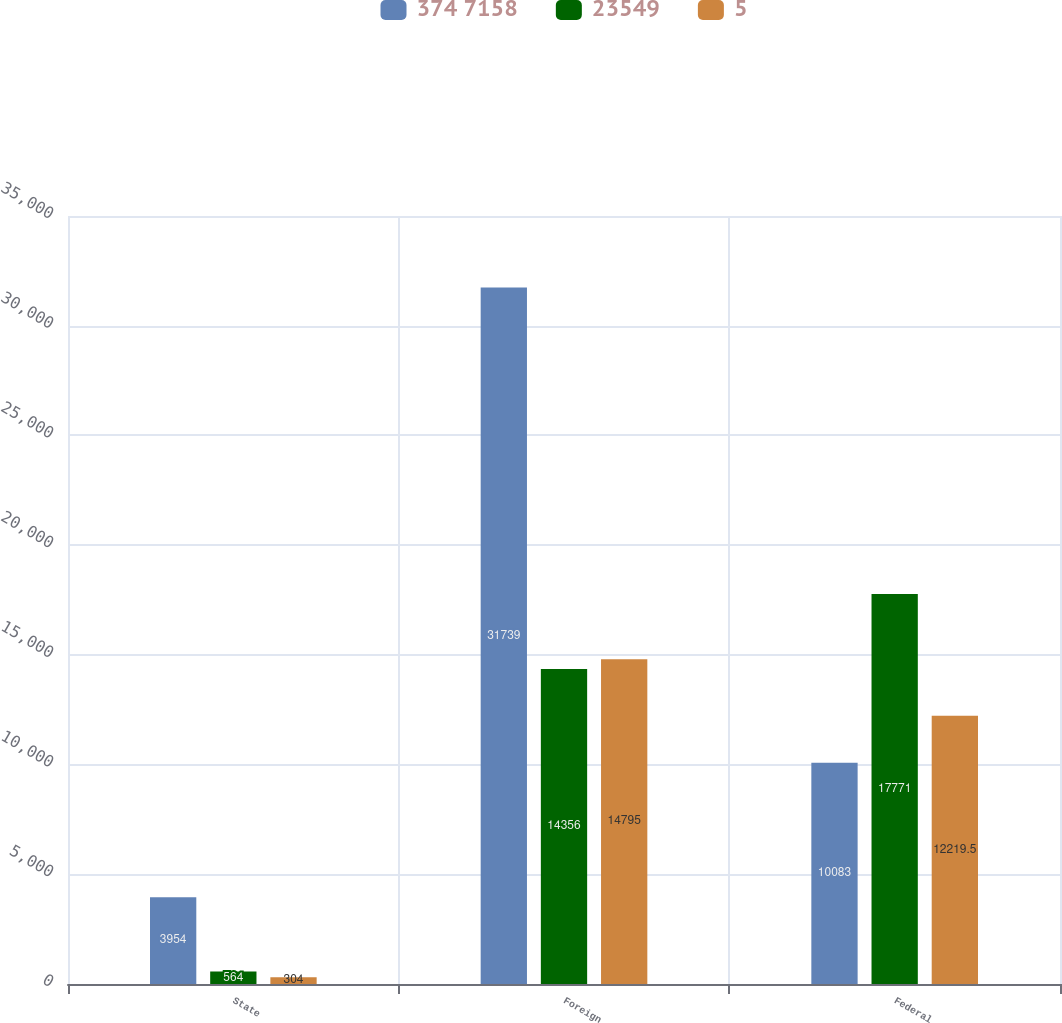<chart> <loc_0><loc_0><loc_500><loc_500><stacked_bar_chart><ecel><fcel>State<fcel>Foreign<fcel>Federal<nl><fcel>374 7158<fcel>3954<fcel>31739<fcel>10083<nl><fcel>23549<fcel>564<fcel>14356<fcel>17771<nl><fcel>5<fcel>304<fcel>14795<fcel>12219.5<nl></chart> 